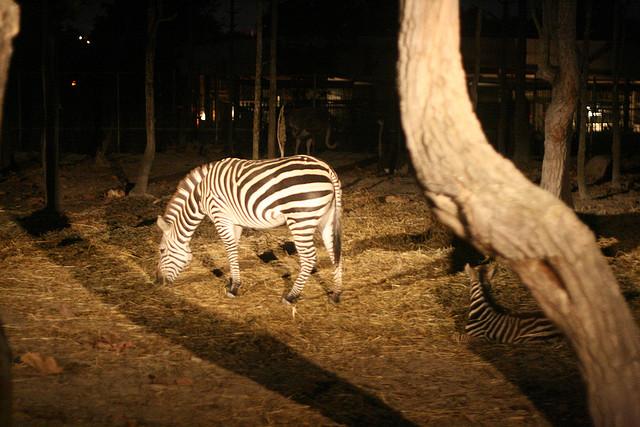How many zebras are in the picture?
Answer briefly. 2. Is he grazing?
Answer briefly. Yes. What time of day is it?
Write a very short answer. Night. 